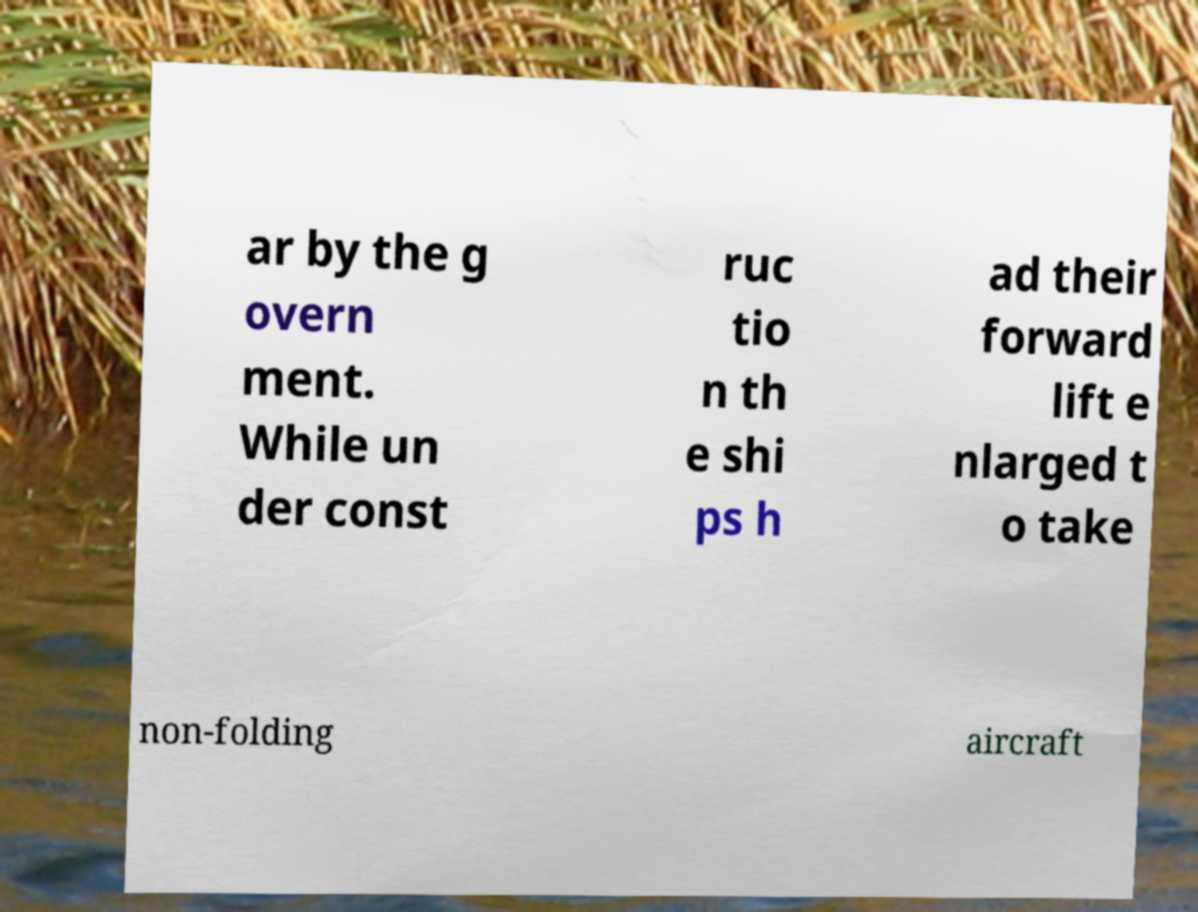For documentation purposes, I need the text within this image transcribed. Could you provide that? ar by the g overn ment. While un der const ruc tio n th e shi ps h ad their forward lift e nlarged t o take non-folding aircraft 